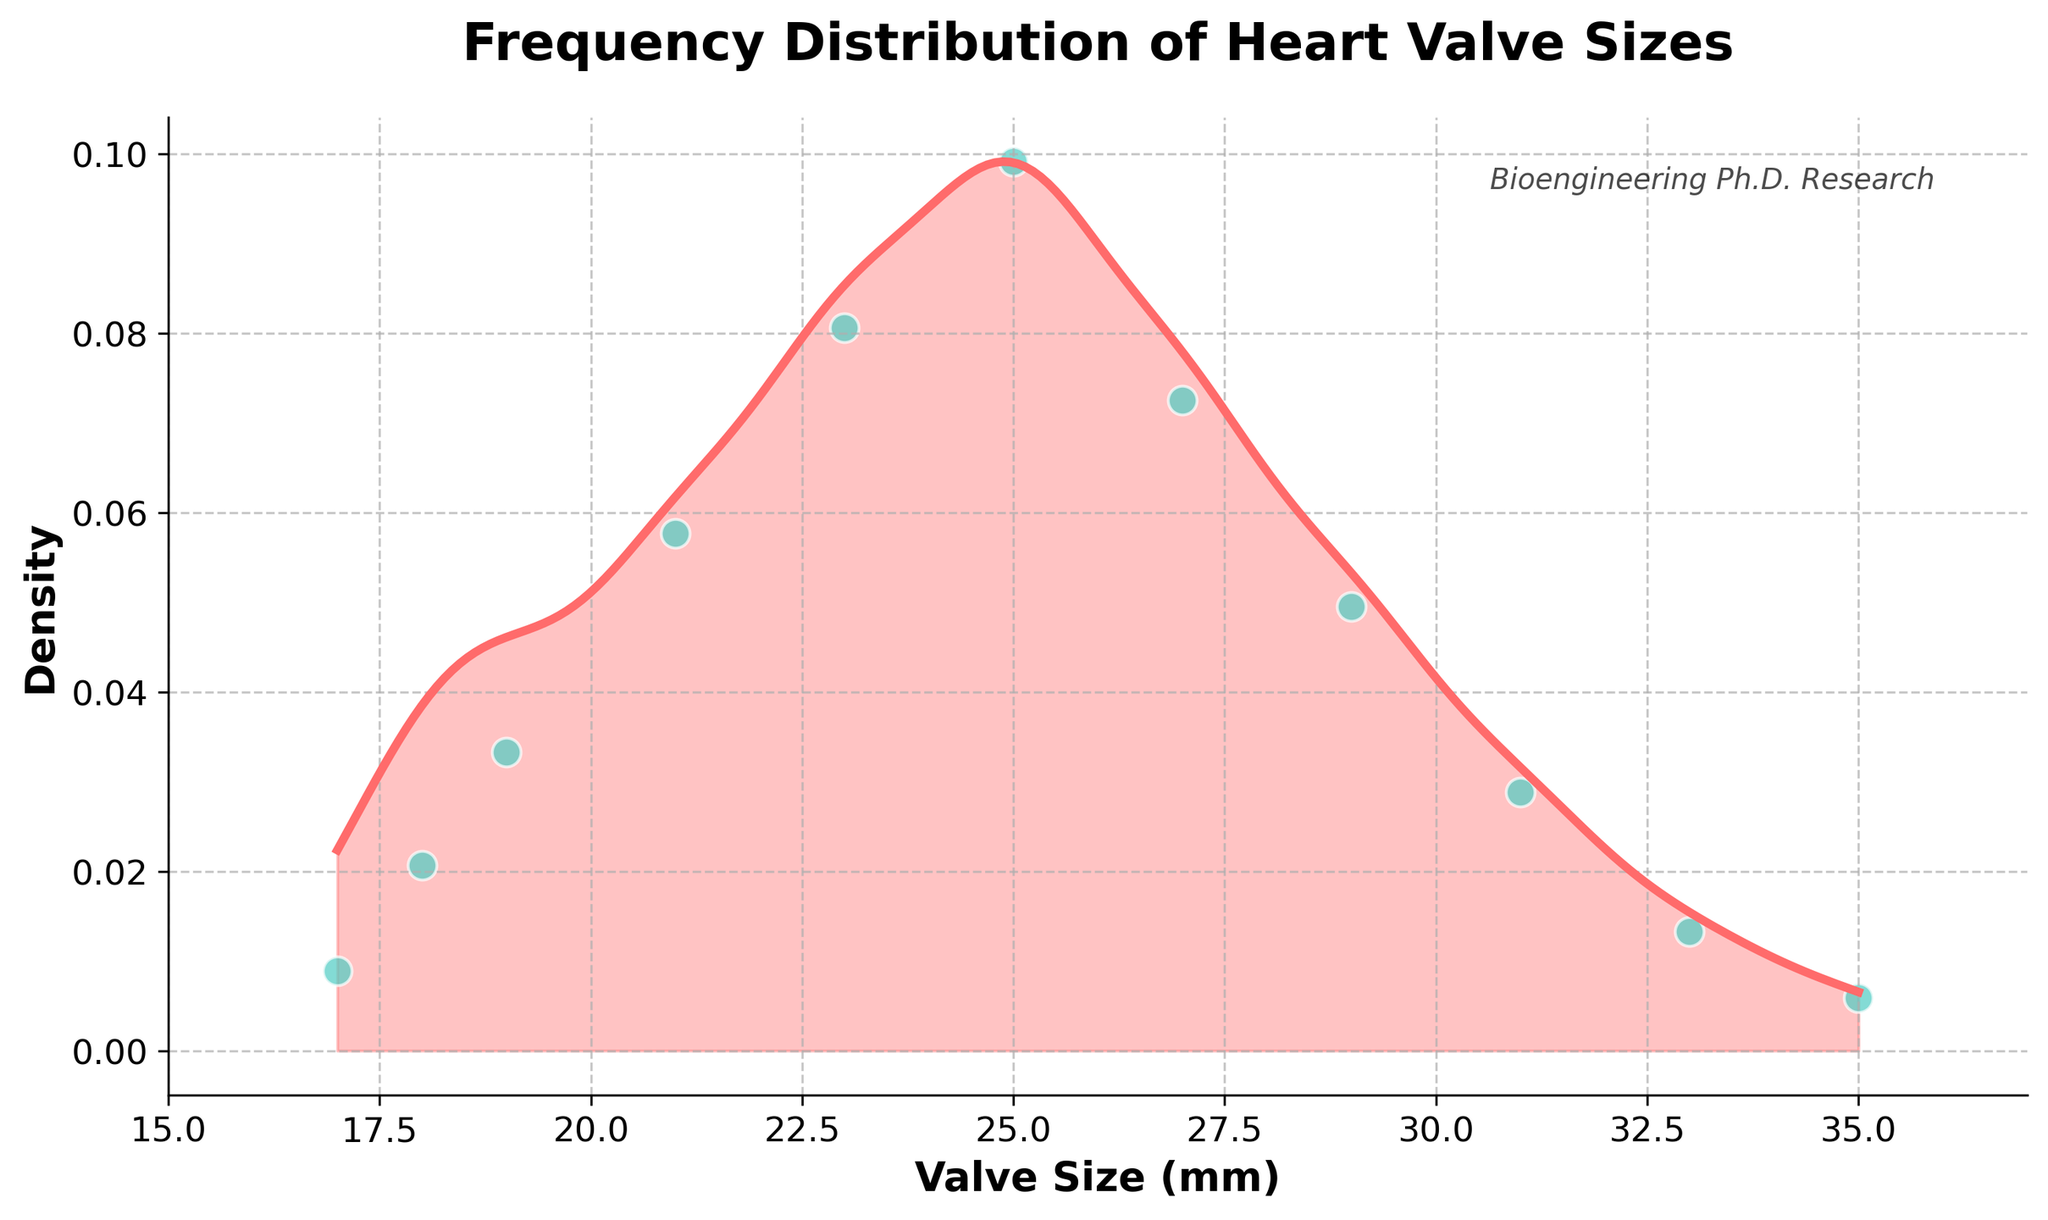what is the title of the plot? The title of the plot is located at the top center of the figure and is typically one of the most prominent text elements in a plot. Here, the title is "Frequency Distribution of Heart Valve Sizes".
Answer: Frequency Distribution of Heart Valve Sizes What does the x-axis represent? The x-axis label is located at the bottom of the plot. It represents the range of values for "Valve Size (mm)".
Answer: Valve Size (mm) What does the y-axis represent? The y-axis label is located on the left side of the plot. It represents the "Density" of the valve size distribution.
Answer: Density How many data points are shown as scatter points? The scatter points in the plot represent the original data points. To count them, observe the distinct data points along the x-axis. There are 11 such points.
Answer: 11 Which valve size has the highest frequency? To determine the valve size with the highest frequency, look for the highest density peak in the plot. This peak corresponds to a valve size of approximately 25 mm.
Answer: 25 mm What is the range of valve sizes shown in the plot? To find the range, observe the minimum and maximum values on the x-axis. These values range from 17 mm to 35 mm.
Answer: 17 mm to 35 mm Compare the density of valve sizes at 21 mm and 27 mm. Which is higher? By examining the density plot, the peak for 21 mm appears down compared to 27 mm. Hence, the density at 27 mm is higher.
Answer: 27 mm What can you infer about the distribution of valve sizes based on the density plot? The density plot shows two major peaks, indicating that valve sizes around 23-25 mm and 27 mm are more common. There are smaller peaks or plateaus at 21 mm and 31 mm. Overall, the distribution is somewhat bimodal with heavier weight towards the middle sizes.
Answer: Bimodal with peaks around 25 mm and 27 mm What is the overall trend in the frequency distribution of valve sizes? Looking at the density plot, there is a rise in density from 17 mm up to around 25 mm, after which it declines with a smaller peak at 27 mm before decreasing again.
Answer: Increasing up to 25 mm, with a smaller peak at 27 mm How does the frequency of valve sizes at 19 mm compare to that at 33 mm? From the scatter points and density plot, 19 mm has a higher frequency than 33 mm, as indicated by the higher peak and larger scatter point at 19 mm.
Answer: 19 mm is higher 